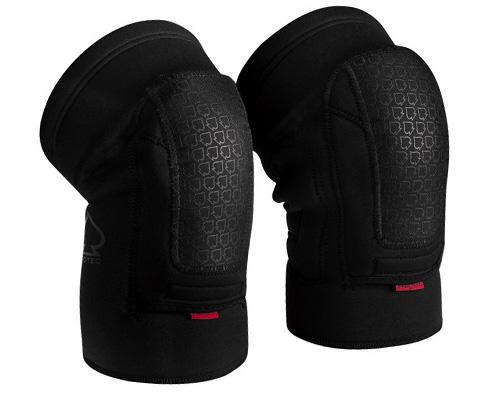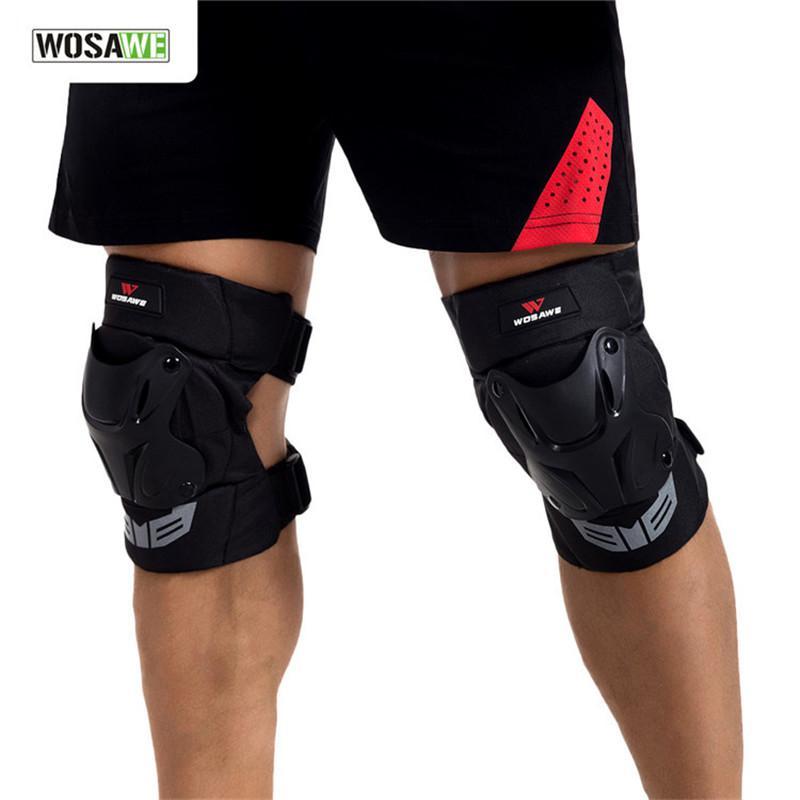The first image is the image on the left, the second image is the image on the right. Analyze the images presented: Is the assertion "The left and right image contains the same number of knee pads." valid? Answer yes or no. Yes. The first image is the image on the left, the second image is the image on the right. Considering the images on both sides, is "One image shows a pair of legs in shorts wearing a pair of black knee pads, and the other image features an unworn pair of black kneepads." valid? Answer yes or no. Yes. 